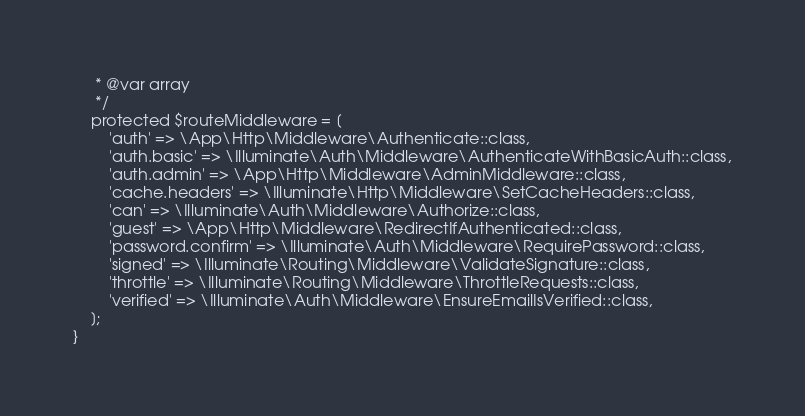<code> <loc_0><loc_0><loc_500><loc_500><_PHP_>     * @var array
     */
    protected $routeMiddleware = [
        'auth' => \App\Http\Middleware\Authenticate::class,
        'auth.basic' => \Illuminate\Auth\Middleware\AuthenticateWithBasicAuth::class,
        'auth.admin' => \App\Http\Middleware\AdminMiddleware::class,
        'cache.headers' => \Illuminate\Http\Middleware\SetCacheHeaders::class,
        'can' => \Illuminate\Auth\Middleware\Authorize::class,
        'guest' => \App\Http\Middleware\RedirectIfAuthenticated::class,
        'password.confirm' => \Illuminate\Auth\Middleware\RequirePassword::class,
        'signed' => \Illuminate\Routing\Middleware\ValidateSignature::class,
        'throttle' => \Illuminate\Routing\Middleware\ThrottleRequests::class,
        'verified' => \Illuminate\Auth\Middleware\EnsureEmailIsVerified::class,
    ];
}
</code> 